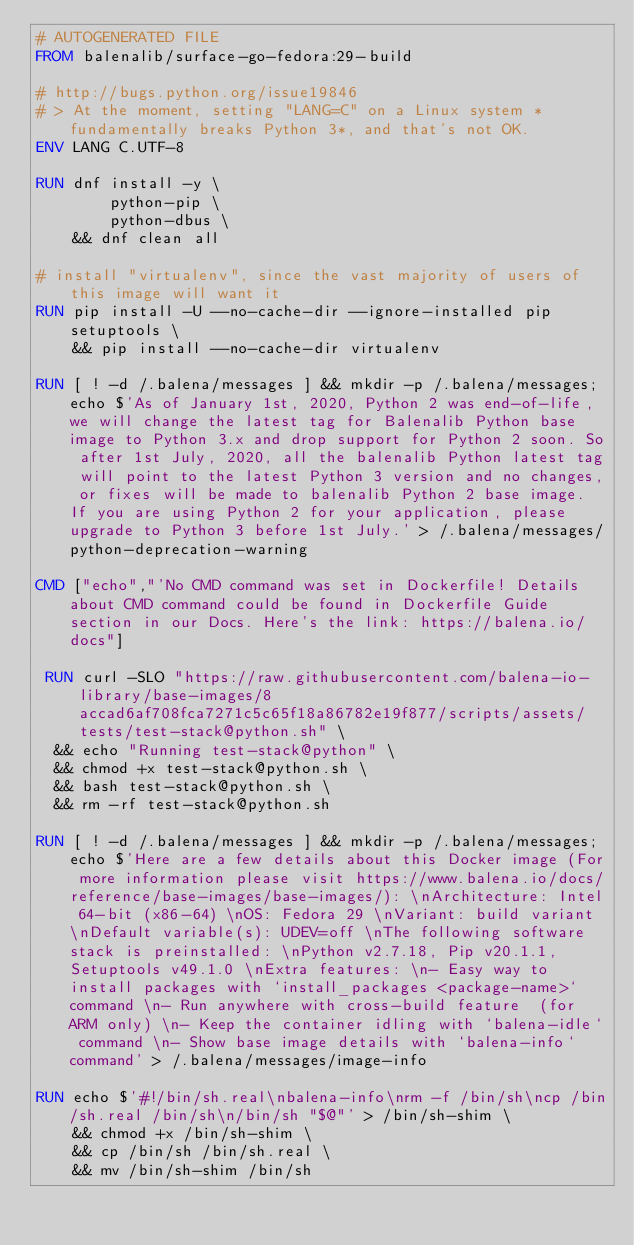<code> <loc_0><loc_0><loc_500><loc_500><_Dockerfile_># AUTOGENERATED FILE
FROM balenalib/surface-go-fedora:29-build

# http://bugs.python.org/issue19846
# > At the moment, setting "LANG=C" on a Linux system *fundamentally breaks Python 3*, and that's not OK.
ENV LANG C.UTF-8

RUN dnf install -y \
		python-pip \
		python-dbus \
	&& dnf clean all

# install "virtualenv", since the vast majority of users of this image will want it
RUN pip install -U --no-cache-dir --ignore-installed pip setuptools \
	&& pip install --no-cache-dir virtualenv

RUN [ ! -d /.balena/messages ] && mkdir -p /.balena/messages; echo $'As of January 1st, 2020, Python 2 was end-of-life, we will change the latest tag for Balenalib Python base image to Python 3.x and drop support for Python 2 soon. So after 1st July, 2020, all the balenalib Python latest tag will point to the latest Python 3 version and no changes, or fixes will be made to balenalib Python 2 base image. If you are using Python 2 for your application, please upgrade to Python 3 before 1st July.' > /.balena/messages/python-deprecation-warning

CMD ["echo","'No CMD command was set in Dockerfile! Details about CMD command could be found in Dockerfile Guide section in our Docs. Here's the link: https://balena.io/docs"]

 RUN curl -SLO "https://raw.githubusercontent.com/balena-io-library/base-images/8accad6af708fca7271c5c65f18a86782e19f877/scripts/assets/tests/test-stack@python.sh" \
  && echo "Running test-stack@python" \
  && chmod +x test-stack@python.sh \
  && bash test-stack@python.sh \
  && rm -rf test-stack@python.sh 

RUN [ ! -d /.balena/messages ] && mkdir -p /.balena/messages; echo $'Here are a few details about this Docker image (For more information please visit https://www.balena.io/docs/reference/base-images/base-images/): \nArchitecture: Intel 64-bit (x86-64) \nOS: Fedora 29 \nVariant: build variant \nDefault variable(s): UDEV=off \nThe following software stack is preinstalled: \nPython v2.7.18, Pip v20.1.1, Setuptools v49.1.0 \nExtra features: \n- Easy way to install packages with `install_packages <package-name>` command \n- Run anywhere with cross-build feature  (for ARM only) \n- Keep the container idling with `balena-idle` command \n- Show base image details with `balena-info` command' > /.balena/messages/image-info

RUN echo $'#!/bin/sh.real\nbalena-info\nrm -f /bin/sh\ncp /bin/sh.real /bin/sh\n/bin/sh "$@"' > /bin/sh-shim \
	&& chmod +x /bin/sh-shim \
	&& cp /bin/sh /bin/sh.real \
	&& mv /bin/sh-shim /bin/sh</code> 